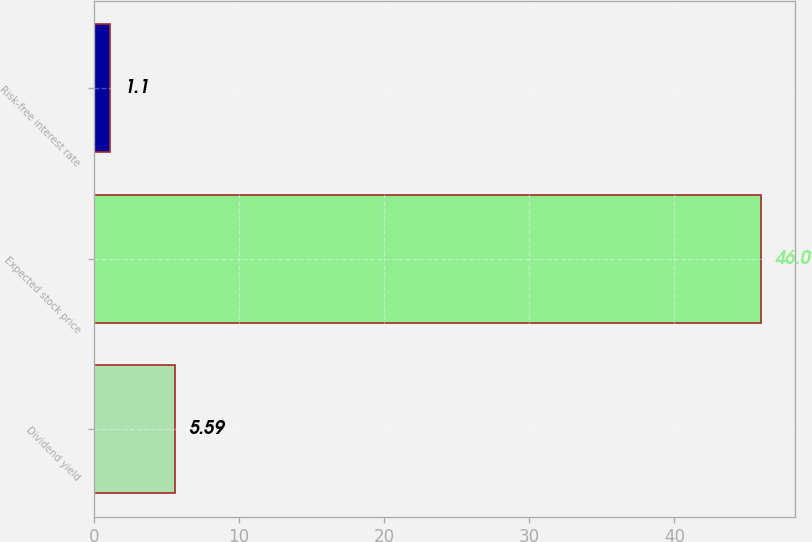<chart> <loc_0><loc_0><loc_500><loc_500><bar_chart><fcel>Dividend yield<fcel>Expected stock price<fcel>Risk-free interest rate<nl><fcel>5.59<fcel>46<fcel>1.1<nl></chart> 